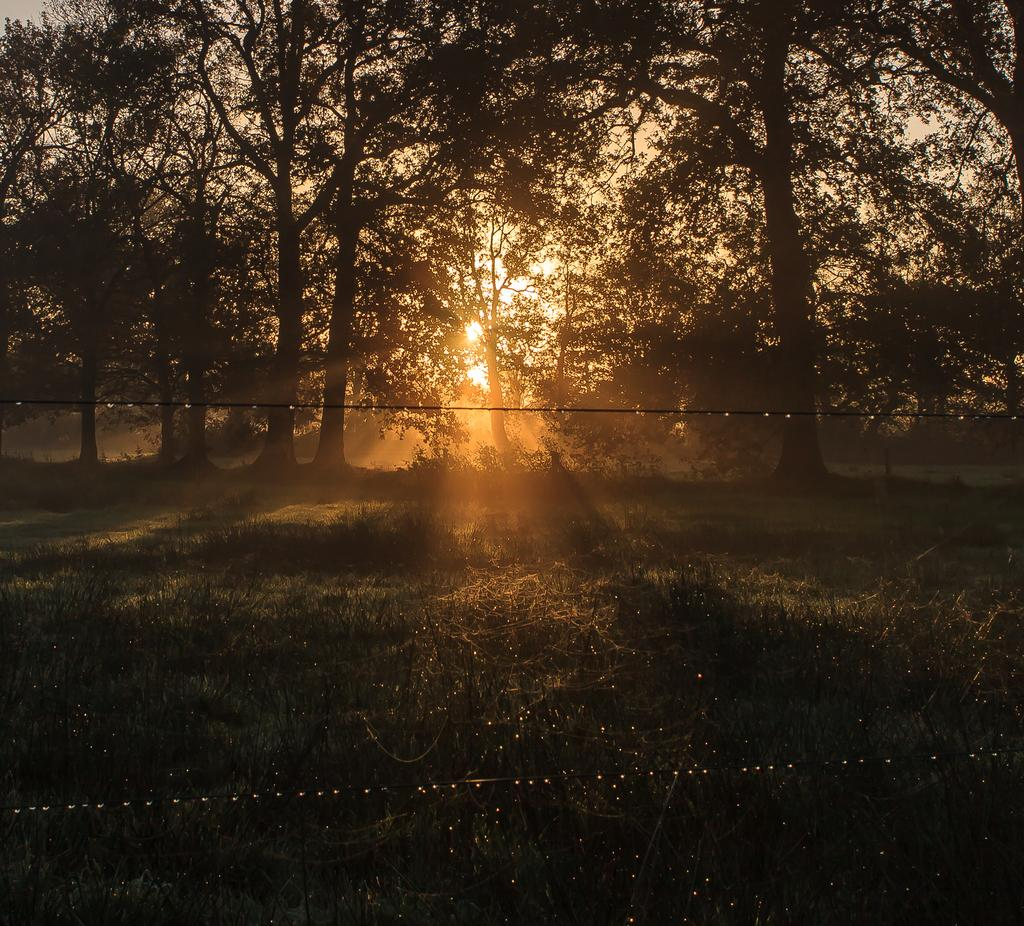What type of vegetation can be seen in the image? There are trees in the image. What else can be seen in the image besides trees? There are wires and grass visible in the image. What is the background of the image? The background of the image includes the sunset. What part of the natural environment is visible in the image set in? The image is set in an area with grass and trees. Can you see a robin perched on the wires in the image? There is no robin present in the image; only trees, wires, and grass are visible. Is there an island in the background of the image? There is no island present in the image; the background features the sunset and the sky. 